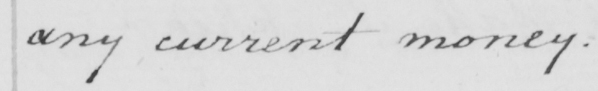Please transcribe the handwritten text in this image. any current money . 